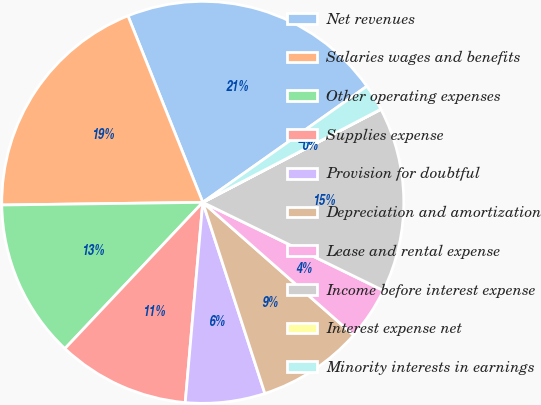<chart> <loc_0><loc_0><loc_500><loc_500><pie_chart><fcel>Net revenues<fcel>Salaries wages and benefits<fcel>Other operating expenses<fcel>Supplies expense<fcel>Provision for doubtful<fcel>Depreciation and amortization<fcel>Lease and rental expense<fcel>Income before interest expense<fcel>Interest expense net<fcel>Minority interests in earnings<nl><fcel>21.27%<fcel>19.14%<fcel>12.76%<fcel>10.64%<fcel>6.39%<fcel>8.51%<fcel>4.26%<fcel>14.89%<fcel>0.01%<fcel>2.13%<nl></chart> 